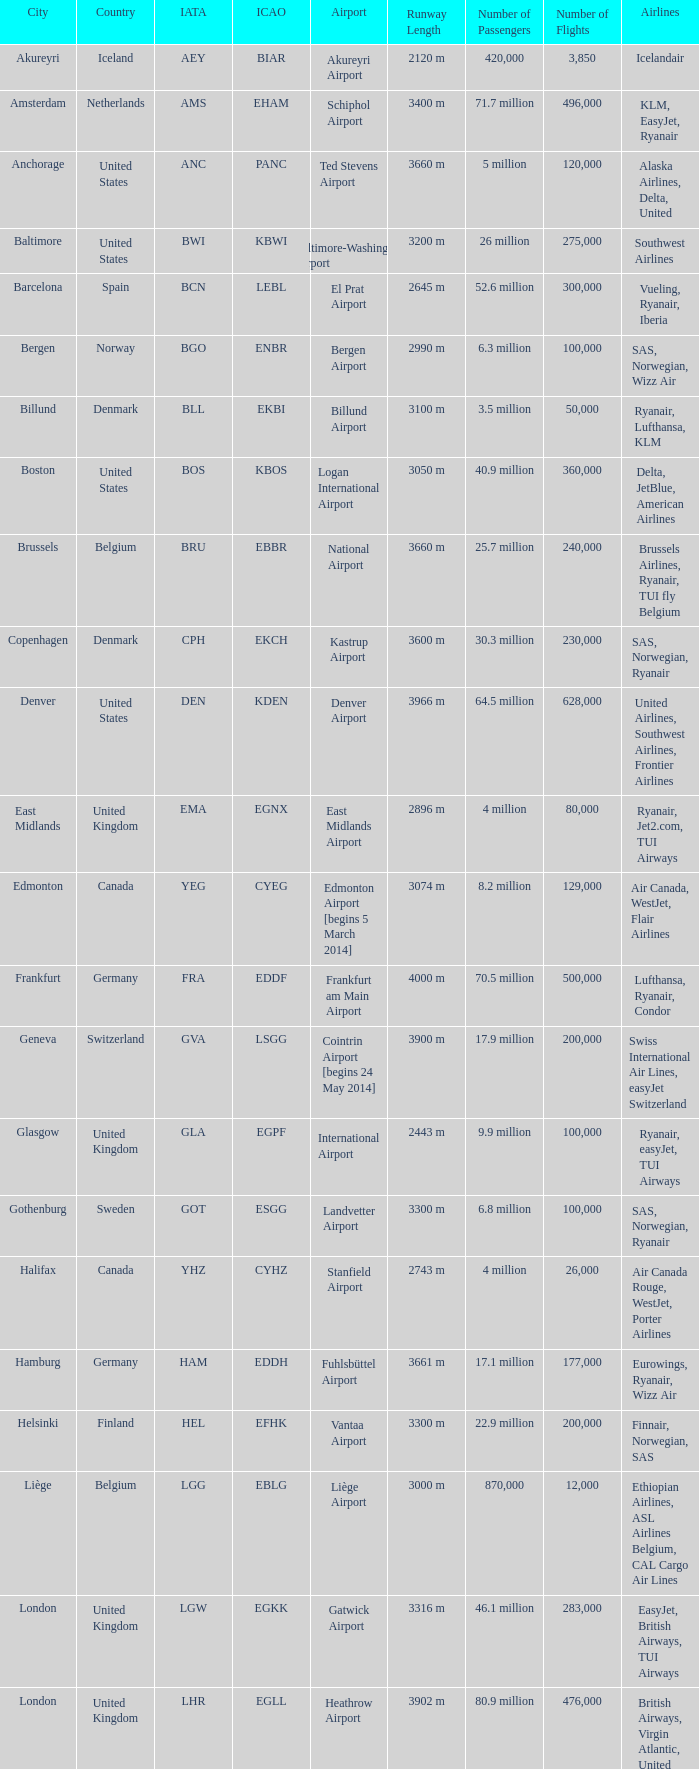What is the City with an IATA of MUC? Munich. 